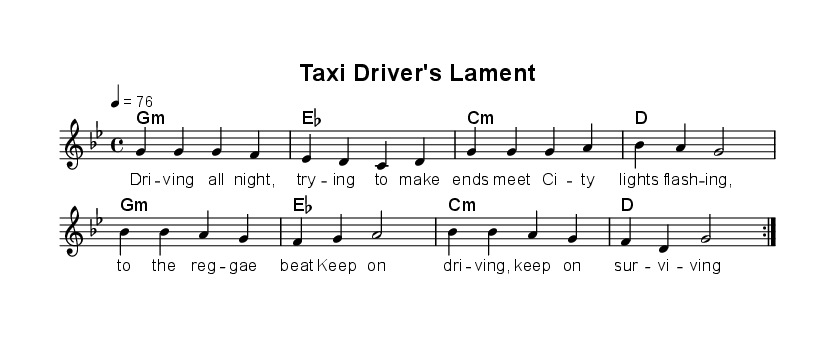What is the key signature of this music? The key signature is G minor, which has two flats (B flat and E flat). This can be identified from the key indication at the beginning of the score before the time signature.
Answer: G minor What is the time signature of this song? The time signature is 4/4, indicating that there are four beats in each measure and a quarter note receives one beat. This is clearly marked at the beginning of the score alongside the key signature.
Answer: 4/4 What is the tempo marking for the piece? The tempo marking is 4 equals 76, which indicates that the beats are counted at 76 beats per minute. This tempo is specified in the global context section of the score.
Answer: 76 How many measures are there in each repeat of the verse? Each repeat of the verse contains four measures, as evidenced by the four sets of notes grouped within the repeat sign before the volta.
Answer: 4 What type of chords are primarily used in this reggae piece? The chords primarily used are minor chords, as seen in the chord mode section where "g1:m", "c:m", and "es" indicate minor chords throughout the progression.
Answer: minor Which lyrical theme does the piece express? The lyrics express the struggles of a working-class life, as evident from phrases about driving all night and trying to make ends meet, which reflect common themes in reggae music about hardship.
Answer: struggles of working-class life What is the form of the song in terms of repeated sections? The form of the song includes repeated sections as indicated by the volta markings, which suggest that both the verse and chorus are intended to be repeated twice in the structure.
Answer: repeated sections 